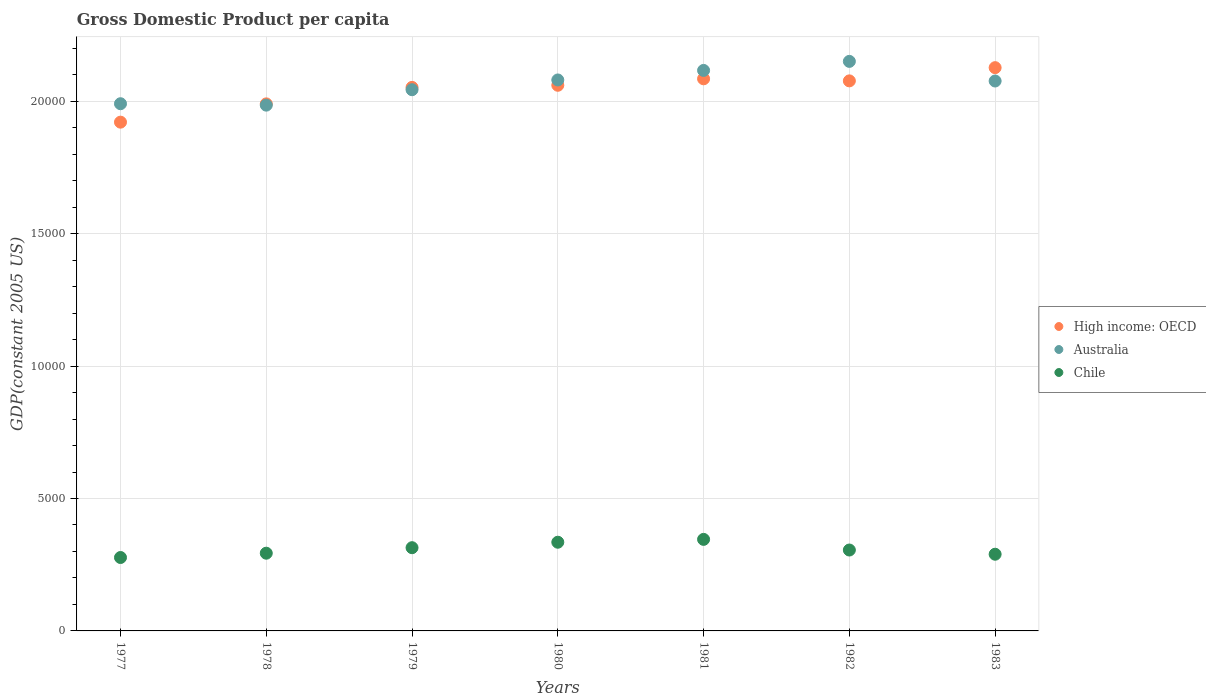How many different coloured dotlines are there?
Offer a terse response. 3. Is the number of dotlines equal to the number of legend labels?
Keep it short and to the point. Yes. What is the GDP per capita in Chile in 1978?
Give a very brief answer. 2934.63. Across all years, what is the maximum GDP per capita in High income: OECD?
Keep it short and to the point. 2.13e+04. Across all years, what is the minimum GDP per capita in High income: OECD?
Keep it short and to the point. 1.92e+04. In which year was the GDP per capita in Australia maximum?
Keep it short and to the point. 1982. In which year was the GDP per capita in Australia minimum?
Provide a succinct answer. 1978. What is the total GDP per capita in Chile in the graph?
Your answer should be very brief. 2.16e+04. What is the difference between the GDP per capita in High income: OECD in 1978 and that in 1983?
Provide a succinct answer. -1367.26. What is the difference between the GDP per capita in Chile in 1981 and the GDP per capita in High income: OECD in 1982?
Keep it short and to the point. -1.73e+04. What is the average GDP per capita in Chile per year?
Provide a short and direct response. 3086.45. In the year 1982, what is the difference between the GDP per capita in Australia and GDP per capita in Chile?
Provide a short and direct response. 1.85e+04. What is the ratio of the GDP per capita in Chile in 1977 to that in 1980?
Your answer should be compact. 0.83. Is the difference between the GDP per capita in Australia in 1978 and 1980 greater than the difference between the GDP per capita in Chile in 1978 and 1980?
Your response must be concise. No. What is the difference between the highest and the second highest GDP per capita in Australia?
Offer a terse response. 341.3. What is the difference between the highest and the lowest GDP per capita in Australia?
Provide a short and direct response. 1652.4. Is the sum of the GDP per capita in Australia in 1978 and 1981 greater than the maximum GDP per capita in High income: OECD across all years?
Make the answer very short. Yes. Is it the case that in every year, the sum of the GDP per capita in High income: OECD and GDP per capita in Australia  is greater than the GDP per capita in Chile?
Your response must be concise. Yes. Does the GDP per capita in High income: OECD monotonically increase over the years?
Offer a very short reply. No. How many years are there in the graph?
Make the answer very short. 7. Does the graph contain grids?
Keep it short and to the point. Yes. Where does the legend appear in the graph?
Your answer should be very brief. Center right. How many legend labels are there?
Keep it short and to the point. 3. How are the legend labels stacked?
Ensure brevity in your answer.  Vertical. What is the title of the graph?
Keep it short and to the point. Gross Domestic Product per capita. Does "Malta" appear as one of the legend labels in the graph?
Offer a very short reply. No. What is the label or title of the Y-axis?
Offer a very short reply. GDP(constant 2005 US). What is the GDP(constant 2005 US) of High income: OECD in 1977?
Provide a succinct answer. 1.92e+04. What is the GDP(constant 2005 US) in Australia in 1977?
Give a very brief answer. 1.99e+04. What is the GDP(constant 2005 US) of Chile in 1977?
Make the answer very short. 2771.88. What is the GDP(constant 2005 US) of High income: OECD in 1978?
Your answer should be very brief. 1.99e+04. What is the GDP(constant 2005 US) of Australia in 1978?
Your answer should be very brief. 1.99e+04. What is the GDP(constant 2005 US) of Chile in 1978?
Provide a succinct answer. 2934.63. What is the GDP(constant 2005 US) of High income: OECD in 1979?
Keep it short and to the point. 2.05e+04. What is the GDP(constant 2005 US) of Australia in 1979?
Offer a terse response. 2.04e+04. What is the GDP(constant 2005 US) of Chile in 1979?
Provide a succinct answer. 3142.66. What is the GDP(constant 2005 US) in High income: OECD in 1980?
Your answer should be very brief. 2.06e+04. What is the GDP(constant 2005 US) of Australia in 1980?
Your answer should be very brief. 2.08e+04. What is the GDP(constant 2005 US) in Chile in 1980?
Offer a very short reply. 3349.08. What is the GDP(constant 2005 US) in High income: OECD in 1981?
Ensure brevity in your answer.  2.08e+04. What is the GDP(constant 2005 US) of Australia in 1981?
Offer a very short reply. 2.12e+04. What is the GDP(constant 2005 US) of Chile in 1981?
Keep it short and to the point. 3456.62. What is the GDP(constant 2005 US) in High income: OECD in 1982?
Keep it short and to the point. 2.08e+04. What is the GDP(constant 2005 US) of Australia in 1982?
Provide a short and direct response. 2.15e+04. What is the GDP(constant 2005 US) of Chile in 1982?
Your answer should be very brief. 3054.6. What is the GDP(constant 2005 US) in High income: OECD in 1983?
Ensure brevity in your answer.  2.13e+04. What is the GDP(constant 2005 US) of Australia in 1983?
Your response must be concise. 2.08e+04. What is the GDP(constant 2005 US) of Chile in 1983?
Your response must be concise. 2895.65. Across all years, what is the maximum GDP(constant 2005 US) of High income: OECD?
Your response must be concise. 2.13e+04. Across all years, what is the maximum GDP(constant 2005 US) in Australia?
Keep it short and to the point. 2.15e+04. Across all years, what is the maximum GDP(constant 2005 US) of Chile?
Give a very brief answer. 3456.62. Across all years, what is the minimum GDP(constant 2005 US) in High income: OECD?
Provide a succinct answer. 1.92e+04. Across all years, what is the minimum GDP(constant 2005 US) of Australia?
Keep it short and to the point. 1.99e+04. Across all years, what is the minimum GDP(constant 2005 US) of Chile?
Keep it short and to the point. 2771.88. What is the total GDP(constant 2005 US) of High income: OECD in the graph?
Offer a very short reply. 1.43e+05. What is the total GDP(constant 2005 US) in Australia in the graph?
Give a very brief answer. 1.44e+05. What is the total GDP(constant 2005 US) in Chile in the graph?
Keep it short and to the point. 2.16e+04. What is the difference between the GDP(constant 2005 US) in High income: OECD in 1977 and that in 1978?
Offer a very short reply. -690.49. What is the difference between the GDP(constant 2005 US) in Australia in 1977 and that in 1978?
Offer a very short reply. 53.66. What is the difference between the GDP(constant 2005 US) of Chile in 1977 and that in 1978?
Provide a succinct answer. -162.74. What is the difference between the GDP(constant 2005 US) in High income: OECD in 1977 and that in 1979?
Make the answer very short. -1312.77. What is the difference between the GDP(constant 2005 US) of Australia in 1977 and that in 1979?
Provide a short and direct response. -528.91. What is the difference between the GDP(constant 2005 US) in Chile in 1977 and that in 1979?
Offer a very short reply. -370.78. What is the difference between the GDP(constant 2005 US) in High income: OECD in 1977 and that in 1980?
Make the answer very short. -1392.55. What is the difference between the GDP(constant 2005 US) in Australia in 1977 and that in 1980?
Provide a succinct answer. -897.34. What is the difference between the GDP(constant 2005 US) of Chile in 1977 and that in 1980?
Your response must be concise. -577.2. What is the difference between the GDP(constant 2005 US) of High income: OECD in 1977 and that in 1981?
Make the answer very short. -1636.86. What is the difference between the GDP(constant 2005 US) in Australia in 1977 and that in 1981?
Provide a short and direct response. -1257.44. What is the difference between the GDP(constant 2005 US) in Chile in 1977 and that in 1981?
Your answer should be compact. -684.74. What is the difference between the GDP(constant 2005 US) in High income: OECD in 1977 and that in 1982?
Your answer should be very brief. -1558.87. What is the difference between the GDP(constant 2005 US) of Australia in 1977 and that in 1982?
Your response must be concise. -1598.74. What is the difference between the GDP(constant 2005 US) of Chile in 1977 and that in 1982?
Ensure brevity in your answer.  -282.71. What is the difference between the GDP(constant 2005 US) in High income: OECD in 1977 and that in 1983?
Provide a succinct answer. -2057.75. What is the difference between the GDP(constant 2005 US) in Australia in 1977 and that in 1983?
Give a very brief answer. -857.75. What is the difference between the GDP(constant 2005 US) of Chile in 1977 and that in 1983?
Make the answer very short. -123.77. What is the difference between the GDP(constant 2005 US) of High income: OECD in 1978 and that in 1979?
Your answer should be very brief. -622.28. What is the difference between the GDP(constant 2005 US) of Australia in 1978 and that in 1979?
Provide a short and direct response. -582.57. What is the difference between the GDP(constant 2005 US) in Chile in 1978 and that in 1979?
Ensure brevity in your answer.  -208.03. What is the difference between the GDP(constant 2005 US) of High income: OECD in 1978 and that in 1980?
Your answer should be compact. -702.06. What is the difference between the GDP(constant 2005 US) of Australia in 1978 and that in 1980?
Ensure brevity in your answer.  -951. What is the difference between the GDP(constant 2005 US) in Chile in 1978 and that in 1980?
Make the answer very short. -414.46. What is the difference between the GDP(constant 2005 US) in High income: OECD in 1978 and that in 1981?
Keep it short and to the point. -946.38. What is the difference between the GDP(constant 2005 US) in Australia in 1978 and that in 1981?
Give a very brief answer. -1311.1. What is the difference between the GDP(constant 2005 US) of Chile in 1978 and that in 1981?
Provide a succinct answer. -521.99. What is the difference between the GDP(constant 2005 US) in High income: OECD in 1978 and that in 1982?
Keep it short and to the point. -868.38. What is the difference between the GDP(constant 2005 US) of Australia in 1978 and that in 1982?
Give a very brief answer. -1652.4. What is the difference between the GDP(constant 2005 US) in Chile in 1978 and that in 1982?
Give a very brief answer. -119.97. What is the difference between the GDP(constant 2005 US) of High income: OECD in 1978 and that in 1983?
Provide a short and direct response. -1367.26. What is the difference between the GDP(constant 2005 US) in Australia in 1978 and that in 1983?
Make the answer very short. -911.41. What is the difference between the GDP(constant 2005 US) of Chile in 1978 and that in 1983?
Your answer should be compact. 38.97. What is the difference between the GDP(constant 2005 US) in High income: OECD in 1979 and that in 1980?
Your answer should be compact. -79.78. What is the difference between the GDP(constant 2005 US) of Australia in 1979 and that in 1980?
Your answer should be very brief. -368.42. What is the difference between the GDP(constant 2005 US) of Chile in 1979 and that in 1980?
Keep it short and to the point. -206.42. What is the difference between the GDP(constant 2005 US) in High income: OECD in 1979 and that in 1981?
Provide a short and direct response. -324.09. What is the difference between the GDP(constant 2005 US) of Australia in 1979 and that in 1981?
Your answer should be very brief. -728.53. What is the difference between the GDP(constant 2005 US) of Chile in 1979 and that in 1981?
Your answer should be very brief. -313.96. What is the difference between the GDP(constant 2005 US) in High income: OECD in 1979 and that in 1982?
Your answer should be compact. -246.1. What is the difference between the GDP(constant 2005 US) in Australia in 1979 and that in 1982?
Ensure brevity in your answer.  -1069.83. What is the difference between the GDP(constant 2005 US) in Chile in 1979 and that in 1982?
Keep it short and to the point. 88.06. What is the difference between the GDP(constant 2005 US) in High income: OECD in 1979 and that in 1983?
Make the answer very short. -744.97. What is the difference between the GDP(constant 2005 US) in Australia in 1979 and that in 1983?
Offer a terse response. -328.84. What is the difference between the GDP(constant 2005 US) in Chile in 1979 and that in 1983?
Your response must be concise. 247.01. What is the difference between the GDP(constant 2005 US) in High income: OECD in 1980 and that in 1981?
Give a very brief answer. -244.31. What is the difference between the GDP(constant 2005 US) of Australia in 1980 and that in 1981?
Offer a very short reply. -360.1. What is the difference between the GDP(constant 2005 US) of Chile in 1980 and that in 1981?
Offer a terse response. -107.54. What is the difference between the GDP(constant 2005 US) in High income: OECD in 1980 and that in 1982?
Ensure brevity in your answer.  -166.32. What is the difference between the GDP(constant 2005 US) of Australia in 1980 and that in 1982?
Make the answer very short. -701.4. What is the difference between the GDP(constant 2005 US) of Chile in 1980 and that in 1982?
Make the answer very short. 294.49. What is the difference between the GDP(constant 2005 US) in High income: OECD in 1980 and that in 1983?
Make the answer very short. -665.2. What is the difference between the GDP(constant 2005 US) of Australia in 1980 and that in 1983?
Provide a short and direct response. 39.59. What is the difference between the GDP(constant 2005 US) in Chile in 1980 and that in 1983?
Ensure brevity in your answer.  453.43. What is the difference between the GDP(constant 2005 US) of High income: OECD in 1981 and that in 1982?
Ensure brevity in your answer.  78. What is the difference between the GDP(constant 2005 US) of Australia in 1981 and that in 1982?
Your answer should be very brief. -341.3. What is the difference between the GDP(constant 2005 US) of Chile in 1981 and that in 1982?
Provide a short and direct response. 402.02. What is the difference between the GDP(constant 2005 US) in High income: OECD in 1981 and that in 1983?
Your answer should be very brief. -420.88. What is the difference between the GDP(constant 2005 US) in Australia in 1981 and that in 1983?
Provide a short and direct response. 399.69. What is the difference between the GDP(constant 2005 US) of Chile in 1981 and that in 1983?
Offer a terse response. 560.97. What is the difference between the GDP(constant 2005 US) in High income: OECD in 1982 and that in 1983?
Provide a short and direct response. -498.88. What is the difference between the GDP(constant 2005 US) of Australia in 1982 and that in 1983?
Provide a short and direct response. 740.99. What is the difference between the GDP(constant 2005 US) in Chile in 1982 and that in 1983?
Offer a very short reply. 158.95. What is the difference between the GDP(constant 2005 US) in High income: OECD in 1977 and the GDP(constant 2005 US) in Australia in 1978?
Your answer should be very brief. -642.48. What is the difference between the GDP(constant 2005 US) in High income: OECD in 1977 and the GDP(constant 2005 US) in Chile in 1978?
Provide a succinct answer. 1.63e+04. What is the difference between the GDP(constant 2005 US) of Australia in 1977 and the GDP(constant 2005 US) of Chile in 1978?
Provide a succinct answer. 1.70e+04. What is the difference between the GDP(constant 2005 US) in High income: OECD in 1977 and the GDP(constant 2005 US) in Australia in 1979?
Make the answer very short. -1225.06. What is the difference between the GDP(constant 2005 US) of High income: OECD in 1977 and the GDP(constant 2005 US) of Chile in 1979?
Offer a very short reply. 1.61e+04. What is the difference between the GDP(constant 2005 US) of Australia in 1977 and the GDP(constant 2005 US) of Chile in 1979?
Offer a terse response. 1.68e+04. What is the difference between the GDP(constant 2005 US) of High income: OECD in 1977 and the GDP(constant 2005 US) of Australia in 1980?
Your response must be concise. -1593.48. What is the difference between the GDP(constant 2005 US) of High income: OECD in 1977 and the GDP(constant 2005 US) of Chile in 1980?
Ensure brevity in your answer.  1.59e+04. What is the difference between the GDP(constant 2005 US) in Australia in 1977 and the GDP(constant 2005 US) in Chile in 1980?
Your answer should be very brief. 1.66e+04. What is the difference between the GDP(constant 2005 US) in High income: OECD in 1977 and the GDP(constant 2005 US) in Australia in 1981?
Make the answer very short. -1953.58. What is the difference between the GDP(constant 2005 US) of High income: OECD in 1977 and the GDP(constant 2005 US) of Chile in 1981?
Provide a succinct answer. 1.58e+04. What is the difference between the GDP(constant 2005 US) of Australia in 1977 and the GDP(constant 2005 US) of Chile in 1981?
Provide a short and direct response. 1.64e+04. What is the difference between the GDP(constant 2005 US) of High income: OECD in 1977 and the GDP(constant 2005 US) of Australia in 1982?
Provide a short and direct response. -2294.89. What is the difference between the GDP(constant 2005 US) of High income: OECD in 1977 and the GDP(constant 2005 US) of Chile in 1982?
Your answer should be compact. 1.62e+04. What is the difference between the GDP(constant 2005 US) of Australia in 1977 and the GDP(constant 2005 US) of Chile in 1982?
Your answer should be very brief. 1.69e+04. What is the difference between the GDP(constant 2005 US) in High income: OECD in 1977 and the GDP(constant 2005 US) in Australia in 1983?
Your response must be concise. -1553.89. What is the difference between the GDP(constant 2005 US) of High income: OECD in 1977 and the GDP(constant 2005 US) of Chile in 1983?
Offer a very short reply. 1.63e+04. What is the difference between the GDP(constant 2005 US) of Australia in 1977 and the GDP(constant 2005 US) of Chile in 1983?
Ensure brevity in your answer.  1.70e+04. What is the difference between the GDP(constant 2005 US) in High income: OECD in 1978 and the GDP(constant 2005 US) in Australia in 1979?
Give a very brief answer. -534.57. What is the difference between the GDP(constant 2005 US) of High income: OECD in 1978 and the GDP(constant 2005 US) of Chile in 1979?
Your answer should be compact. 1.68e+04. What is the difference between the GDP(constant 2005 US) in Australia in 1978 and the GDP(constant 2005 US) in Chile in 1979?
Your response must be concise. 1.67e+04. What is the difference between the GDP(constant 2005 US) of High income: OECD in 1978 and the GDP(constant 2005 US) of Australia in 1980?
Provide a succinct answer. -902.99. What is the difference between the GDP(constant 2005 US) of High income: OECD in 1978 and the GDP(constant 2005 US) of Chile in 1980?
Provide a succinct answer. 1.66e+04. What is the difference between the GDP(constant 2005 US) of Australia in 1978 and the GDP(constant 2005 US) of Chile in 1980?
Offer a very short reply. 1.65e+04. What is the difference between the GDP(constant 2005 US) in High income: OECD in 1978 and the GDP(constant 2005 US) in Australia in 1981?
Give a very brief answer. -1263.09. What is the difference between the GDP(constant 2005 US) of High income: OECD in 1978 and the GDP(constant 2005 US) of Chile in 1981?
Offer a very short reply. 1.64e+04. What is the difference between the GDP(constant 2005 US) in Australia in 1978 and the GDP(constant 2005 US) in Chile in 1981?
Ensure brevity in your answer.  1.64e+04. What is the difference between the GDP(constant 2005 US) in High income: OECD in 1978 and the GDP(constant 2005 US) in Australia in 1982?
Provide a short and direct response. -1604.4. What is the difference between the GDP(constant 2005 US) of High income: OECD in 1978 and the GDP(constant 2005 US) of Chile in 1982?
Your answer should be compact. 1.68e+04. What is the difference between the GDP(constant 2005 US) in Australia in 1978 and the GDP(constant 2005 US) in Chile in 1982?
Your answer should be very brief. 1.68e+04. What is the difference between the GDP(constant 2005 US) of High income: OECD in 1978 and the GDP(constant 2005 US) of Australia in 1983?
Provide a short and direct response. -863.41. What is the difference between the GDP(constant 2005 US) of High income: OECD in 1978 and the GDP(constant 2005 US) of Chile in 1983?
Your answer should be compact. 1.70e+04. What is the difference between the GDP(constant 2005 US) of Australia in 1978 and the GDP(constant 2005 US) of Chile in 1983?
Provide a succinct answer. 1.70e+04. What is the difference between the GDP(constant 2005 US) of High income: OECD in 1979 and the GDP(constant 2005 US) of Australia in 1980?
Keep it short and to the point. -280.71. What is the difference between the GDP(constant 2005 US) in High income: OECD in 1979 and the GDP(constant 2005 US) in Chile in 1980?
Your answer should be compact. 1.72e+04. What is the difference between the GDP(constant 2005 US) in Australia in 1979 and the GDP(constant 2005 US) in Chile in 1980?
Ensure brevity in your answer.  1.71e+04. What is the difference between the GDP(constant 2005 US) in High income: OECD in 1979 and the GDP(constant 2005 US) in Australia in 1981?
Keep it short and to the point. -640.81. What is the difference between the GDP(constant 2005 US) in High income: OECD in 1979 and the GDP(constant 2005 US) in Chile in 1981?
Ensure brevity in your answer.  1.71e+04. What is the difference between the GDP(constant 2005 US) of Australia in 1979 and the GDP(constant 2005 US) of Chile in 1981?
Your answer should be compact. 1.70e+04. What is the difference between the GDP(constant 2005 US) in High income: OECD in 1979 and the GDP(constant 2005 US) in Australia in 1982?
Your answer should be compact. -982.11. What is the difference between the GDP(constant 2005 US) in High income: OECD in 1979 and the GDP(constant 2005 US) in Chile in 1982?
Offer a terse response. 1.75e+04. What is the difference between the GDP(constant 2005 US) in Australia in 1979 and the GDP(constant 2005 US) in Chile in 1982?
Your answer should be very brief. 1.74e+04. What is the difference between the GDP(constant 2005 US) in High income: OECD in 1979 and the GDP(constant 2005 US) in Australia in 1983?
Your answer should be very brief. -241.12. What is the difference between the GDP(constant 2005 US) of High income: OECD in 1979 and the GDP(constant 2005 US) of Chile in 1983?
Offer a terse response. 1.76e+04. What is the difference between the GDP(constant 2005 US) in Australia in 1979 and the GDP(constant 2005 US) in Chile in 1983?
Keep it short and to the point. 1.75e+04. What is the difference between the GDP(constant 2005 US) of High income: OECD in 1980 and the GDP(constant 2005 US) of Australia in 1981?
Make the answer very short. -561.03. What is the difference between the GDP(constant 2005 US) in High income: OECD in 1980 and the GDP(constant 2005 US) in Chile in 1981?
Offer a terse response. 1.71e+04. What is the difference between the GDP(constant 2005 US) in Australia in 1980 and the GDP(constant 2005 US) in Chile in 1981?
Your answer should be compact. 1.73e+04. What is the difference between the GDP(constant 2005 US) in High income: OECD in 1980 and the GDP(constant 2005 US) in Australia in 1982?
Ensure brevity in your answer.  -902.33. What is the difference between the GDP(constant 2005 US) of High income: OECD in 1980 and the GDP(constant 2005 US) of Chile in 1982?
Give a very brief answer. 1.75e+04. What is the difference between the GDP(constant 2005 US) in Australia in 1980 and the GDP(constant 2005 US) in Chile in 1982?
Your answer should be very brief. 1.77e+04. What is the difference between the GDP(constant 2005 US) of High income: OECD in 1980 and the GDP(constant 2005 US) of Australia in 1983?
Your response must be concise. -161.34. What is the difference between the GDP(constant 2005 US) in High income: OECD in 1980 and the GDP(constant 2005 US) in Chile in 1983?
Keep it short and to the point. 1.77e+04. What is the difference between the GDP(constant 2005 US) of Australia in 1980 and the GDP(constant 2005 US) of Chile in 1983?
Make the answer very short. 1.79e+04. What is the difference between the GDP(constant 2005 US) of High income: OECD in 1981 and the GDP(constant 2005 US) of Australia in 1982?
Your answer should be very brief. -658.02. What is the difference between the GDP(constant 2005 US) of High income: OECD in 1981 and the GDP(constant 2005 US) of Chile in 1982?
Provide a succinct answer. 1.78e+04. What is the difference between the GDP(constant 2005 US) of Australia in 1981 and the GDP(constant 2005 US) of Chile in 1982?
Your response must be concise. 1.81e+04. What is the difference between the GDP(constant 2005 US) in High income: OECD in 1981 and the GDP(constant 2005 US) in Australia in 1983?
Your answer should be compact. 82.97. What is the difference between the GDP(constant 2005 US) in High income: OECD in 1981 and the GDP(constant 2005 US) in Chile in 1983?
Your answer should be very brief. 1.80e+04. What is the difference between the GDP(constant 2005 US) in Australia in 1981 and the GDP(constant 2005 US) in Chile in 1983?
Your response must be concise. 1.83e+04. What is the difference between the GDP(constant 2005 US) in High income: OECD in 1982 and the GDP(constant 2005 US) in Australia in 1983?
Offer a very short reply. 4.98. What is the difference between the GDP(constant 2005 US) of High income: OECD in 1982 and the GDP(constant 2005 US) of Chile in 1983?
Your answer should be compact. 1.79e+04. What is the difference between the GDP(constant 2005 US) of Australia in 1982 and the GDP(constant 2005 US) of Chile in 1983?
Keep it short and to the point. 1.86e+04. What is the average GDP(constant 2005 US) of High income: OECD per year?
Give a very brief answer. 2.04e+04. What is the average GDP(constant 2005 US) of Australia per year?
Your answer should be compact. 2.06e+04. What is the average GDP(constant 2005 US) of Chile per year?
Offer a very short reply. 3086.45. In the year 1977, what is the difference between the GDP(constant 2005 US) in High income: OECD and GDP(constant 2005 US) in Australia?
Provide a succinct answer. -696.14. In the year 1977, what is the difference between the GDP(constant 2005 US) of High income: OECD and GDP(constant 2005 US) of Chile?
Your response must be concise. 1.64e+04. In the year 1977, what is the difference between the GDP(constant 2005 US) in Australia and GDP(constant 2005 US) in Chile?
Keep it short and to the point. 1.71e+04. In the year 1978, what is the difference between the GDP(constant 2005 US) of High income: OECD and GDP(constant 2005 US) of Australia?
Make the answer very short. 48. In the year 1978, what is the difference between the GDP(constant 2005 US) of High income: OECD and GDP(constant 2005 US) of Chile?
Ensure brevity in your answer.  1.70e+04. In the year 1978, what is the difference between the GDP(constant 2005 US) in Australia and GDP(constant 2005 US) in Chile?
Ensure brevity in your answer.  1.69e+04. In the year 1979, what is the difference between the GDP(constant 2005 US) of High income: OECD and GDP(constant 2005 US) of Australia?
Your response must be concise. 87.72. In the year 1979, what is the difference between the GDP(constant 2005 US) of High income: OECD and GDP(constant 2005 US) of Chile?
Your response must be concise. 1.74e+04. In the year 1979, what is the difference between the GDP(constant 2005 US) in Australia and GDP(constant 2005 US) in Chile?
Offer a very short reply. 1.73e+04. In the year 1980, what is the difference between the GDP(constant 2005 US) of High income: OECD and GDP(constant 2005 US) of Australia?
Keep it short and to the point. -200.93. In the year 1980, what is the difference between the GDP(constant 2005 US) of High income: OECD and GDP(constant 2005 US) of Chile?
Offer a terse response. 1.73e+04. In the year 1980, what is the difference between the GDP(constant 2005 US) in Australia and GDP(constant 2005 US) in Chile?
Your response must be concise. 1.75e+04. In the year 1981, what is the difference between the GDP(constant 2005 US) of High income: OECD and GDP(constant 2005 US) of Australia?
Your answer should be compact. -316.72. In the year 1981, what is the difference between the GDP(constant 2005 US) of High income: OECD and GDP(constant 2005 US) of Chile?
Give a very brief answer. 1.74e+04. In the year 1981, what is the difference between the GDP(constant 2005 US) of Australia and GDP(constant 2005 US) of Chile?
Provide a succinct answer. 1.77e+04. In the year 1982, what is the difference between the GDP(constant 2005 US) of High income: OECD and GDP(constant 2005 US) of Australia?
Your response must be concise. -736.02. In the year 1982, what is the difference between the GDP(constant 2005 US) in High income: OECD and GDP(constant 2005 US) in Chile?
Your answer should be compact. 1.77e+04. In the year 1982, what is the difference between the GDP(constant 2005 US) of Australia and GDP(constant 2005 US) of Chile?
Offer a terse response. 1.85e+04. In the year 1983, what is the difference between the GDP(constant 2005 US) in High income: OECD and GDP(constant 2005 US) in Australia?
Your response must be concise. 503.85. In the year 1983, what is the difference between the GDP(constant 2005 US) in High income: OECD and GDP(constant 2005 US) in Chile?
Provide a succinct answer. 1.84e+04. In the year 1983, what is the difference between the GDP(constant 2005 US) in Australia and GDP(constant 2005 US) in Chile?
Keep it short and to the point. 1.79e+04. What is the ratio of the GDP(constant 2005 US) of High income: OECD in 1977 to that in 1978?
Your answer should be very brief. 0.97. What is the ratio of the GDP(constant 2005 US) of Chile in 1977 to that in 1978?
Give a very brief answer. 0.94. What is the ratio of the GDP(constant 2005 US) of High income: OECD in 1977 to that in 1979?
Give a very brief answer. 0.94. What is the ratio of the GDP(constant 2005 US) of Australia in 1977 to that in 1979?
Your response must be concise. 0.97. What is the ratio of the GDP(constant 2005 US) in Chile in 1977 to that in 1979?
Offer a very short reply. 0.88. What is the ratio of the GDP(constant 2005 US) in High income: OECD in 1977 to that in 1980?
Provide a succinct answer. 0.93. What is the ratio of the GDP(constant 2005 US) in Australia in 1977 to that in 1980?
Your answer should be compact. 0.96. What is the ratio of the GDP(constant 2005 US) of Chile in 1977 to that in 1980?
Your response must be concise. 0.83. What is the ratio of the GDP(constant 2005 US) of High income: OECD in 1977 to that in 1981?
Make the answer very short. 0.92. What is the ratio of the GDP(constant 2005 US) in Australia in 1977 to that in 1981?
Provide a short and direct response. 0.94. What is the ratio of the GDP(constant 2005 US) of Chile in 1977 to that in 1981?
Make the answer very short. 0.8. What is the ratio of the GDP(constant 2005 US) in High income: OECD in 1977 to that in 1982?
Provide a short and direct response. 0.92. What is the ratio of the GDP(constant 2005 US) in Australia in 1977 to that in 1982?
Ensure brevity in your answer.  0.93. What is the ratio of the GDP(constant 2005 US) in Chile in 1977 to that in 1982?
Provide a short and direct response. 0.91. What is the ratio of the GDP(constant 2005 US) in High income: OECD in 1977 to that in 1983?
Offer a very short reply. 0.9. What is the ratio of the GDP(constant 2005 US) of Australia in 1977 to that in 1983?
Ensure brevity in your answer.  0.96. What is the ratio of the GDP(constant 2005 US) of Chile in 1977 to that in 1983?
Your response must be concise. 0.96. What is the ratio of the GDP(constant 2005 US) in High income: OECD in 1978 to that in 1979?
Offer a terse response. 0.97. What is the ratio of the GDP(constant 2005 US) of Australia in 1978 to that in 1979?
Ensure brevity in your answer.  0.97. What is the ratio of the GDP(constant 2005 US) of Chile in 1978 to that in 1979?
Your answer should be very brief. 0.93. What is the ratio of the GDP(constant 2005 US) in High income: OECD in 1978 to that in 1980?
Keep it short and to the point. 0.97. What is the ratio of the GDP(constant 2005 US) of Australia in 1978 to that in 1980?
Keep it short and to the point. 0.95. What is the ratio of the GDP(constant 2005 US) of Chile in 1978 to that in 1980?
Make the answer very short. 0.88. What is the ratio of the GDP(constant 2005 US) of High income: OECD in 1978 to that in 1981?
Your response must be concise. 0.95. What is the ratio of the GDP(constant 2005 US) of Australia in 1978 to that in 1981?
Your answer should be compact. 0.94. What is the ratio of the GDP(constant 2005 US) in Chile in 1978 to that in 1981?
Ensure brevity in your answer.  0.85. What is the ratio of the GDP(constant 2005 US) of High income: OECD in 1978 to that in 1982?
Offer a terse response. 0.96. What is the ratio of the GDP(constant 2005 US) in Australia in 1978 to that in 1982?
Provide a short and direct response. 0.92. What is the ratio of the GDP(constant 2005 US) of Chile in 1978 to that in 1982?
Your response must be concise. 0.96. What is the ratio of the GDP(constant 2005 US) of High income: OECD in 1978 to that in 1983?
Provide a short and direct response. 0.94. What is the ratio of the GDP(constant 2005 US) in Australia in 1978 to that in 1983?
Ensure brevity in your answer.  0.96. What is the ratio of the GDP(constant 2005 US) of Chile in 1978 to that in 1983?
Ensure brevity in your answer.  1.01. What is the ratio of the GDP(constant 2005 US) of High income: OECD in 1979 to that in 1980?
Offer a terse response. 1. What is the ratio of the GDP(constant 2005 US) of Australia in 1979 to that in 1980?
Keep it short and to the point. 0.98. What is the ratio of the GDP(constant 2005 US) in Chile in 1979 to that in 1980?
Your answer should be compact. 0.94. What is the ratio of the GDP(constant 2005 US) of High income: OECD in 1979 to that in 1981?
Offer a terse response. 0.98. What is the ratio of the GDP(constant 2005 US) in Australia in 1979 to that in 1981?
Your answer should be compact. 0.97. What is the ratio of the GDP(constant 2005 US) of Chile in 1979 to that in 1981?
Your response must be concise. 0.91. What is the ratio of the GDP(constant 2005 US) of High income: OECD in 1979 to that in 1982?
Ensure brevity in your answer.  0.99. What is the ratio of the GDP(constant 2005 US) of Australia in 1979 to that in 1982?
Your answer should be very brief. 0.95. What is the ratio of the GDP(constant 2005 US) of Chile in 1979 to that in 1982?
Give a very brief answer. 1.03. What is the ratio of the GDP(constant 2005 US) in High income: OECD in 1979 to that in 1983?
Your answer should be very brief. 0.96. What is the ratio of the GDP(constant 2005 US) in Australia in 1979 to that in 1983?
Offer a terse response. 0.98. What is the ratio of the GDP(constant 2005 US) of Chile in 1979 to that in 1983?
Provide a short and direct response. 1.09. What is the ratio of the GDP(constant 2005 US) of High income: OECD in 1980 to that in 1981?
Your answer should be very brief. 0.99. What is the ratio of the GDP(constant 2005 US) of Chile in 1980 to that in 1981?
Your answer should be compact. 0.97. What is the ratio of the GDP(constant 2005 US) of Australia in 1980 to that in 1982?
Your answer should be compact. 0.97. What is the ratio of the GDP(constant 2005 US) of Chile in 1980 to that in 1982?
Provide a succinct answer. 1.1. What is the ratio of the GDP(constant 2005 US) in High income: OECD in 1980 to that in 1983?
Ensure brevity in your answer.  0.97. What is the ratio of the GDP(constant 2005 US) of Chile in 1980 to that in 1983?
Your answer should be compact. 1.16. What is the ratio of the GDP(constant 2005 US) in Australia in 1981 to that in 1982?
Offer a very short reply. 0.98. What is the ratio of the GDP(constant 2005 US) in Chile in 1981 to that in 1982?
Your response must be concise. 1.13. What is the ratio of the GDP(constant 2005 US) in High income: OECD in 1981 to that in 1983?
Provide a short and direct response. 0.98. What is the ratio of the GDP(constant 2005 US) of Australia in 1981 to that in 1983?
Offer a terse response. 1.02. What is the ratio of the GDP(constant 2005 US) in Chile in 1981 to that in 1983?
Give a very brief answer. 1.19. What is the ratio of the GDP(constant 2005 US) in High income: OECD in 1982 to that in 1983?
Keep it short and to the point. 0.98. What is the ratio of the GDP(constant 2005 US) of Australia in 1982 to that in 1983?
Your response must be concise. 1.04. What is the ratio of the GDP(constant 2005 US) of Chile in 1982 to that in 1983?
Your answer should be very brief. 1.05. What is the difference between the highest and the second highest GDP(constant 2005 US) in High income: OECD?
Provide a short and direct response. 420.88. What is the difference between the highest and the second highest GDP(constant 2005 US) of Australia?
Give a very brief answer. 341.3. What is the difference between the highest and the second highest GDP(constant 2005 US) of Chile?
Your response must be concise. 107.54. What is the difference between the highest and the lowest GDP(constant 2005 US) in High income: OECD?
Offer a terse response. 2057.75. What is the difference between the highest and the lowest GDP(constant 2005 US) of Australia?
Your answer should be compact. 1652.4. What is the difference between the highest and the lowest GDP(constant 2005 US) of Chile?
Your answer should be compact. 684.74. 